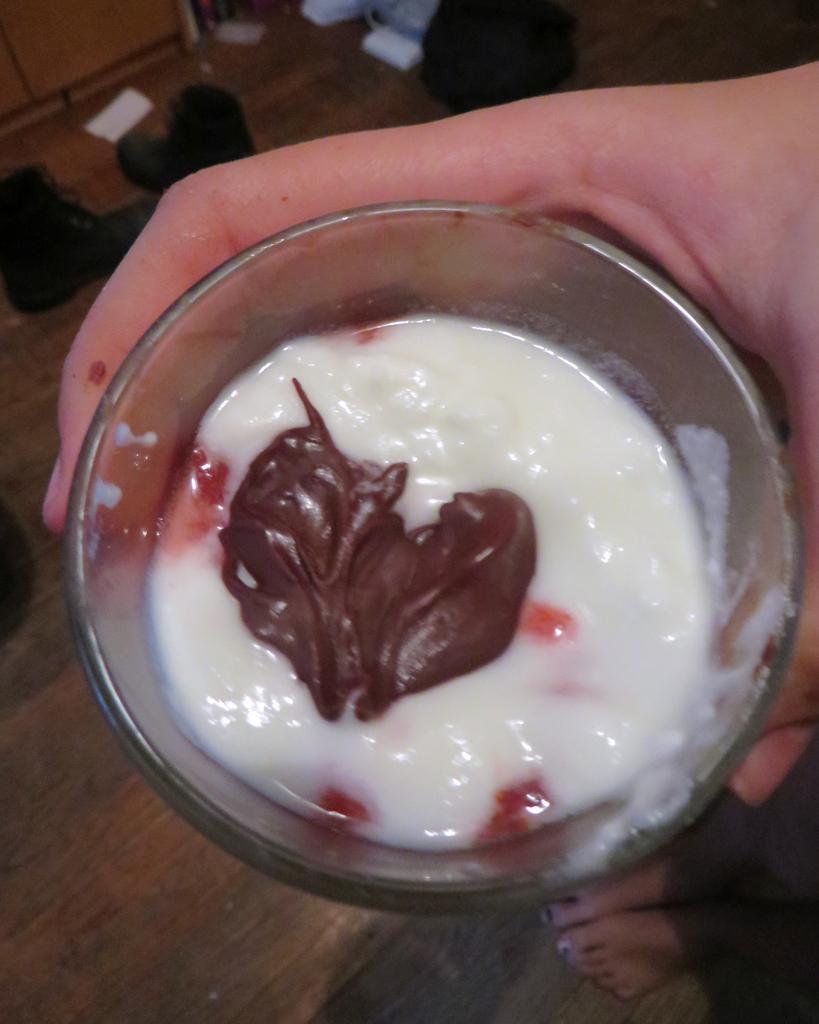Please provide a concise description of this image. In the picture we can see a glass with a cream of white in color and on it we can see a chocolate cream and a person's hand is holding that glass, under it we can see a wooden table. 